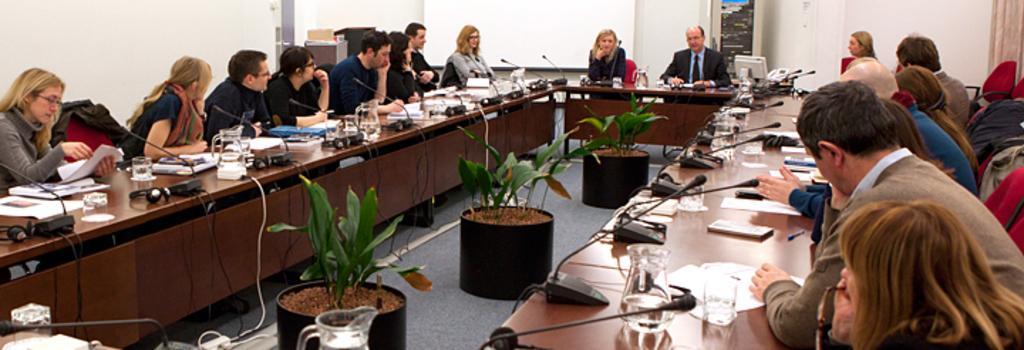How would you summarize this image in a sentence or two? As we can see in the image there a white color wall, banner, few people sitting on chairs and there is a table. On table there are mugs, glasses, papers, tablet, pen, mobile phone, mics, files and between table there are plants. 